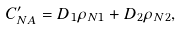Convert formula to latex. <formula><loc_0><loc_0><loc_500><loc_500>C _ { N A } ^ { \prime } = D _ { 1 } \rho _ { N 1 } + D _ { 2 } \rho _ { N 2 } ,</formula> 